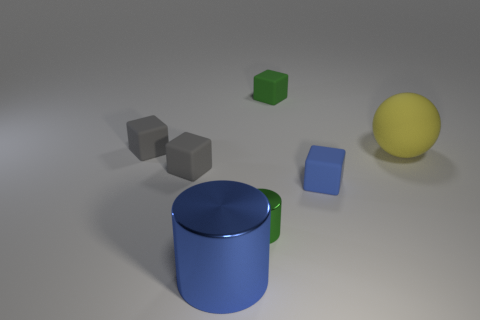Add 1 cyan rubber cylinders. How many objects exist? 8 Subtract all blocks. How many objects are left? 3 Add 7 yellow rubber cylinders. How many yellow rubber cylinders exist? 7 Subtract 0 gray cylinders. How many objects are left? 7 Subtract all small blue cubes. Subtract all big blue cylinders. How many objects are left? 5 Add 2 spheres. How many spheres are left? 3 